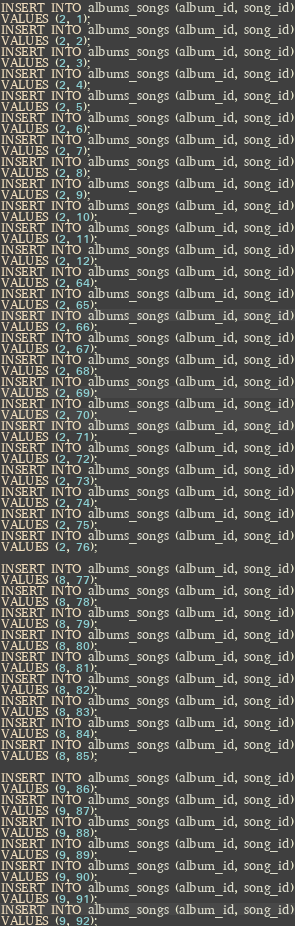Convert code to text. <code><loc_0><loc_0><loc_500><loc_500><_SQL_>INSERT INTO albums_songs (album_id, song_id)
VALUES (2, 1);
INSERT INTO albums_songs (album_id, song_id)
VALUES (2, 2);
INSERT INTO albums_songs (album_id, song_id)
VALUES (2, 3);
INSERT INTO albums_songs (album_id, song_id)
VALUES (2, 4);
INSERT INTO albums_songs (album_id, song_id)
VALUES (2, 5);
INSERT INTO albums_songs (album_id, song_id)
VALUES (2, 6);
INSERT INTO albums_songs (album_id, song_id)
VALUES (2, 7);
INSERT INTO albums_songs (album_id, song_id)
VALUES (2, 8);
INSERT INTO albums_songs (album_id, song_id)
VALUES (2, 9);
INSERT INTO albums_songs (album_id, song_id)
VALUES (2, 10);
INSERT INTO albums_songs (album_id, song_id)
VALUES (2, 11);
INSERT INTO albums_songs (album_id, song_id)
VALUES (2, 12);
INSERT INTO albums_songs (album_id, song_id)
VALUES (2, 64);
INSERT INTO albums_songs (album_id, song_id)
VALUES (2, 65);
INSERT INTO albums_songs (album_id, song_id)
VALUES (2, 66);
INSERT INTO albums_songs (album_id, song_id)
VALUES (2, 67);
INSERT INTO albums_songs (album_id, song_id)
VALUES (2, 68);
INSERT INTO albums_songs (album_id, song_id)
VALUES (2, 69);
INSERT INTO albums_songs (album_id, song_id)
VALUES (2, 70);
INSERT INTO albums_songs (album_id, song_id)
VALUES (2, 71);
INSERT INTO albums_songs (album_id, song_id)
VALUES (2, 72);
INSERT INTO albums_songs (album_id, song_id)
VALUES (2, 73);
INSERT INTO albums_songs (album_id, song_id)
VALUES (2, 74);
INSERT INTO albums_songs (album_id, song_id)
VALUES (2, 75);
INSERT INTO albums_songs (album_id, song_id)
VALUES (2, 76);

INSERT INTO albums_songs (album_id, song_id)
VALUES (8, 77);
INSERT INTO albums_songs (album_id, song_id)
VALUES (8, 78);
INSERT INTO albums_songs (album_id, song_id)
VALUES (8, 79);
INSERT INTO albums_songs (album_id, song_id)
VALUES (8, 80);
INSERT INTO albums_songs (album_id, song_id)
VALUES (8, 81);
INSERT INTO albums_songs (album_id, song_id)
VALUES (8, 82);
INSERT INTO albums_songs (album_id, song_id)
VALUES (8, 83);
INSERT INTO albums_songs (album_id, song_id)
VALUES (8, 84);
INSERT INTO albums_songs (album_id, song_id)
VALUES (8, 85);

INSERT INTO albums_songs (album_id, song_id)
VALUES (9, 86);
INSERT INTO albums_songs (album_id, song_id)
VALUES (9, 87);
INSERT INTO albums_songs (album_id, song_id)
VALUES (9, 88);
INSERT INTO albums_songs (album_id, song_id)
VALUES (9, 89);
INSERT INTO albums_songs (album_id, song_id)
VALUES (9, 90);
INSERT INTO albums_songs (album_id, song_id)
VALUES (9, 91);
INSERT INTO albums_songs (album_id, song_id)
VALUES (9, 92);</code> 